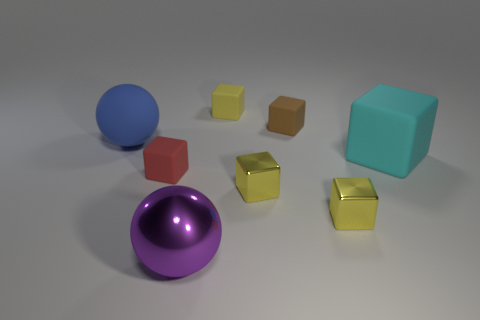Is the red thing made of the same material as the purple sphere?
Keep it short and to the point. No. What number of tiny objects are to the right of the sphere in front of the metal cube right of the brown cube?
Offer a very short reply. 4. What is the color of the big matte object that is the same shape as the small yellow matte object?
Your answer should be compact. Cyan. What shape is the small rubber object that is in front of the big rubber thing that is left of the small rubber block to the left of the metal sphere?
Provide a short and direct response. Cube. How big is the matte block that is both in front of the small brown rubber thing and to the right of the big metallic sphere?
Give a very brief answer. Large. Is the number of big purple spheres less than the number of small things?
Provide a short and direct response. Yes. What size is the sphere that is in front of the large cyan block?
Your answer should be very brief. Large. What shape is the matte thing that is both on the right side of the metal ball and left of the brown cube?
Offer a terse response. Cube. The red rubber object that is the same shape as the large cyan rubber thing is what size?
Your response must be concise. Small. How many large cyan things have the same material as the tiny brown cube?
Your answer should be very brief. 1. 